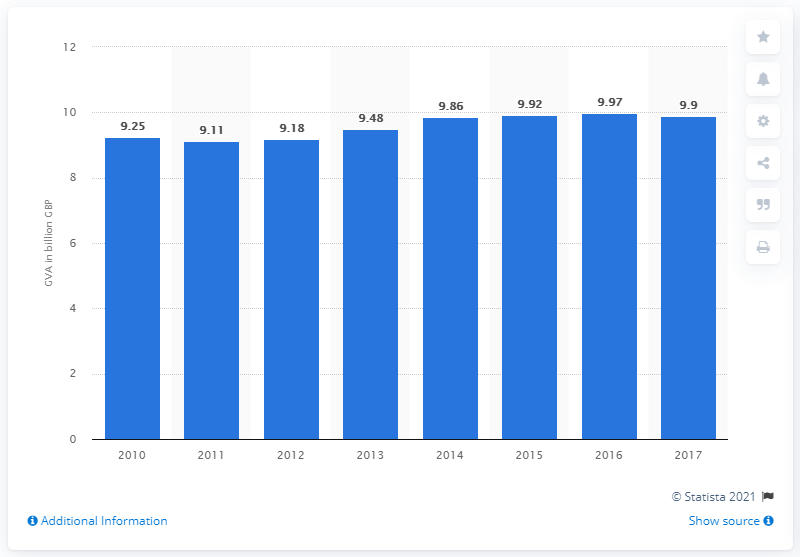Point out several critical features in this image. The gross value added of the publishing industry in 2010 was 9.25. 